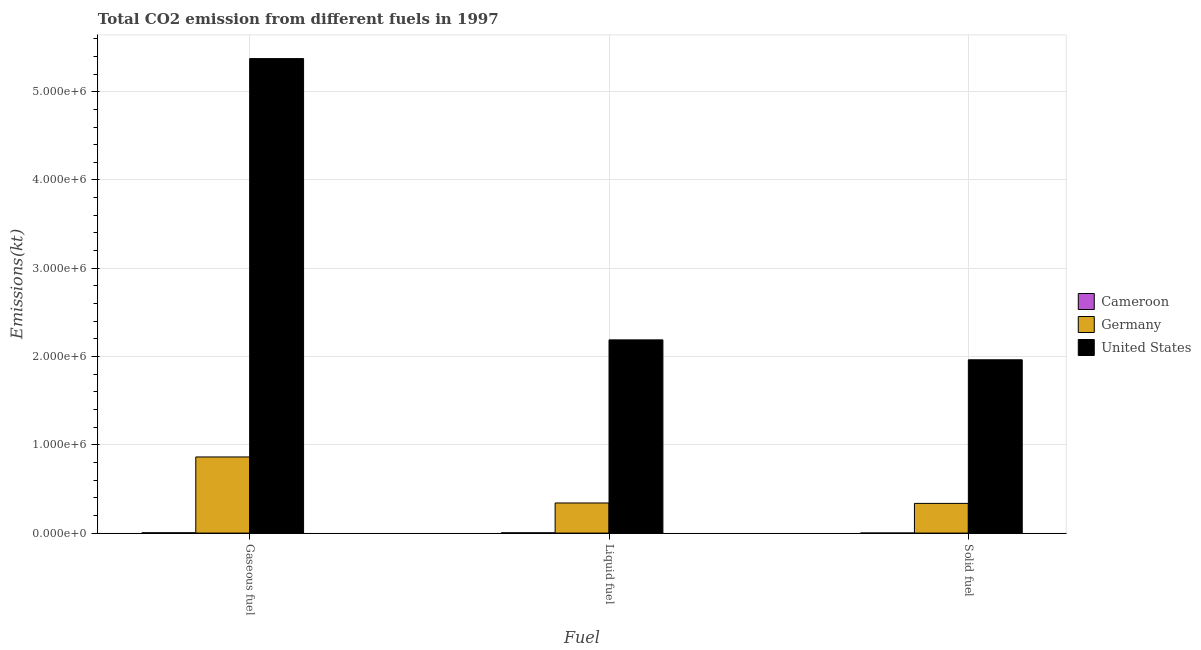How many different coloured bars are there?
Keep it short and to the point. 3. How many groups of bars are there?
Your response must be concise. 3. How many bars are there on the 3rd tick from the left?
Give a very brief answer. 3. How many bars are there on the 3rd tick from the right?
Your answer should be compact. 3. What is the label of the 1st group of bars from the left?
Keep it short and to the point. Gaseous fuel. What is the amount of co2 emissions from liquid fuel in Germany?
Your answer should be very brief. 3.41e+05. Across all countries, what is the maximum amount of co2 emissions from solid fuel?
Ensure brevity in your answer.  1.96e+06. Across all countries, what is the minimum amount of co2 emissions from gaseous fuel?
Keep it short and to the point. 3215.96. In which country was the amount of co2 emissions from liquid fuel minimum?
Your response must be concise. Cameroon. What is the total amount of co2 emissions from liquid fuel in the graph?
Provide a short and direct response. 2.53e+06. What is the difference between the amount of co2 emissions from liquid fuel in United States and that in Cameroon?
Your response must be concise. 2.19e+06. What is the difference between the amount of co2 emissions from solid fuel in Cameroon and the amount of co2 emissions from liquid fuel in United States?
Your answer should be very brief. -2.19e+06. What is the average amount of co2 emissions from liquid fuel per country?
Your answer should be very brief. 8.44e+05. What is the difference between the amount of co2 emissions from gaseous fuel and amount of co2 emissions from liquid fuel in Cameroon?
Provide a short and direct response. 311.7. What is the ratio of the amount of co2 emissions from liquid fuel in Germany to that in United States?
Make the answer very short. 0.16. What is the difference between the highest and the second highest amount of co2 emissions from gaseous fuel?
Your answer should be very brief. 4.51e+06. What is the difference between the highest and the lowest amount of co2 emissions from gaseous fuel?
Offer a very short reply. 5.37e+06. What does the 1st bar from the right in Gaseous fuel represents?
Make the answer very short. United States. How many bars are there?
Ensure brevity in your answer.  9. What is the difference between two consecutive major ticks on the Y-axis?
Offer a very short reply. 1.00e+06. Are the values on the major ticks of Y-axis written in scientific E-notation?
Your answer should be compact. Yes. Does the graph contain any zero values?
Your answer should be compact. No. Does the graph contain grids?
Offer a terse response. Yes. How many legend labels are there?
Ensure brevity in your answer.  3. How are the legend labels stacked?
Offer a terse response. Vertical. What is the title of the graph?
Offer a very short reply. Total CO2 emission from different fuels in 1997. What is the label or title of the X-axis?
Offer a very short reply. Fuel. What is the label or title of the Y-axis?
Make the answer very short. Emissions(kt). What is the Emissions(kt) of Cameroon in Gaseous fuel?
Provide a succinct answer. 3215.96. What is the Emissions(kt) in Germany in Gaseous fuel?
Provide a succinct answer. 8.62e+05. What is the Emissions(kt) of United States in Gaseous fuel?
Offer a very short reply. 5.38e+06. What is the Emissions(kt) in Cameroon in Liquid fuel?
Provide a short and direct response. 2904.26. What is the Emissions(kt) of Germany in Liquid fuel?
Provide a succinct answer. 3.41e+05. What is the Emissions(kt) of United States in Liquid fuel?
Give a very brief answer. 2.19e+06. What is the Emissions(kt) in Cameroon in Solid fuel?
Offer a terse response. 3.67. What is the Emissions(kt) of Germany in Solid fuel?
Your response must be concise. 3.36e+05. What is the Emissions(kt) of United States in Solid fuel?
Make the answer very short. 1.96e+06. Across all Fuel, what is the maximum Emissions(kt) in Cameroon?
Your answer should be compact. 3215.96. Across all Fuel, what is the maximum Emissions(kt) of Germany?
Give a very brief answer. 8.62e+05. Across all Fuel, what is the maximum Emissions(kt) of United States?
Offer a very short reply. 5.38e+06. Across all Fuel, what is the minimum Emissions(kt) in Cameroon?
Keep it short and to the point. 3.67. Across all Fuel, what is the minimum Emissions(kt) of Germany?
Your answer should be compact. 3.36e+05. Across all Fuel, what is the minimum Emissions(kt) of United States?
Make the answer very short. 1.96e+06. What is the total Emissions(kt) of Cameroon in the graph?
Offer a terse response. 6123.89. What is the total Emissions(kt) in Germany in the graph?
Make the answer very short. 1.54e+06. What is the total Emissions(kt) of United States in the graph?
Offer a terse response. 9.53e+06. What is the difference between the Emissions(kt) of Cameroon in Gaseous fuel and that in Liquid fuel?
Your answer should be very brief. 311.69. What is the difference between the Emissions(kt) of Germany in Gaseous fuel and that in Liquid fuel?
Ensure brevity in your answer.  5.21e+05. What is the difference between the Emissions(kt) of United States in Gaseous fuel and that in Liquid fuel?
Your answer should be compact. 3.19e+06. What is the difference between the Emissions(kt) of Cameroon in Gaseous fuel and that in Solid fuel?
Offer a terse response. 3212.29. What is the difference between the Emissions(kt) in Germany in Gaseous fuel and that in Solid fuel?
Provide a succinct answer. 5.26e+05. What is the difference between the Emissions(kt) in United States in Gaseous fuel and that in Solid fuel?
Your answer should be very brief. 3.41e+06. What is the difference between the Emissions(kt) of Cameroon in Liquid fuel and that in Solid fuel?
Offer a very short reply. 2900.6. What is the difference between the Emissions(kt) in Germany in Liquid fuel and that in Solid fuel?
Your answer should be very brief. 4807.44. What is the difference between the Emissions(kt) of United States in Liquid fuel and that in Solid fuel?
Keep it short and to the point. 2.26e+05. What is the difference between the Emissions(kt) in Cameroon in Gaseous fuel and the Emissions(kt) in Germany in Liquid fuel?
Your answer should be compact. -3.38e+05. What is the difference between the Emissions(kt) of Cameroon in Gaseous fuel and the Emissions(kt) of United States in Liquid fuel?
Your answer should be very brief. -2.19e+06. What is the difference between the Emissions(kt) in Germany in Gaseous fuel and the Emissions(kt) in United States in Liquid fuel?
Give a very brief answer. -1.33e+06. What is the difference between the Emissions(kt) in Cameroon in Gaseous fuel and the Emissions(kt) in Germany in Solid fuel?
Make the answer very short. -3.33e+05. What is the difference between the Emissions(kt) of Cameroon in Gaseous fuel and the Emissions(kt) of United States in Solid fuel?
Offer a terse response. -1.96e+06. What is the difference between the Emissions(kt) of Germany in Gaseous fuel and the Emissions(kt) of United States in Solid fuel?
Ensure brevity in your answer.  -1.10e+06. What is the difference between the Emissions(kt) of Cameroon in Liquid fuel and the Emissions(kt) of Germany in Solid fuel?
Your response must be concise. -3.33e+05. What is the difference between the Emissions(kt) of Cameroon in Liquid fuel and the Emissions(kt) of United States in Solid fuel?
Give a very brief answer. -1.96e+06. What is the difference between the Emissions(kt) in Germany in Liquid fuel and the Emissions(kt) in United States in Solid fuel?
Your answer should be compact. -1.62e+06. What is the average Emissions(kt) in Cameroon per Fuel?
Your answer should be very brief. 2041.3. What is the average Emissions(kt) in Germany per Fuel?
Give a very brief answer. 5.13e+05. What is the average Emissions(kt) in United States per Fuel?
Ensure brevity in your answer.  3.18e+06. What is the difference between the Emissions(kt) in Cameroon and Emissions(kt) in Germany in Gaseous fuel?
Keep it short and to the point. -8.59e+05. What is the difference between the Emissions(kt) in Cameroon and Emissions(kt) in United States in Gaseous fuel?
Ensure brevity in your answer.  -5.37e+06. What is the difference between the Emissions(kt) in Germany and Emissions(kt) in United States in Gaseous fuel?
Ensure brevity in your answer.  -4.51e+06. What is the difference between the Emissions(kt) in Cameroon and Emissions(kt) in Germany in Liquid fuel?
Give a very brief answer. -3.38e+05. What is the difference between the Emissions(kt) in Cameroon and Emissions(kt) in United States in Liquid fuel?
Ensure brevity in your answer.  -2.19e+06. What is the difference between the Emissions(kt) of Germany and Emissions(kt) of United States in Liquid fuel?
Offer a terse response. -1.85e+06. What is the difference between the Emissions(kt) of Cameroon and Emissions(kt) of Germany in Solid fuel?
Provide a succinct answer. -3.36e+05. What is the difference between the Emissions(kt) in Cameroon and Emissions(kt) in United States in Solid fuel?
Make the answer very short. -1.96e+06. What is the difference between the Emissions(kt) of Germany and Emissions(kt) of United States in Solid fuel?
Your response must be concise. -1.63e+06. What is the ratio of the Emissions(kt) in Cameroon in Gaseous fuel to that in Liquid fuel?
Your answer should be compact. 1.11. What is the ratio of the Emissions(kt) in Germany in Gaseous fuel to that in Liquid fuel?
Offer a very short reply. 2.53. What is the ratio of the Emissions(kt) in United States in Gaseous fuel to that in Liquid fuel?
Ensure brevity in your answer.  2.46. What is the ratio of the Emissions(kt) of Cameroon in Gaseous fuel to that in Solid fuel?
Provide a succinct answer. 877. What is the ratio of the Emissions(kt) of Germany in Gaseous fuel to that in Solid fuel?
Your answer should be compact. 2.57. What is the ratio of the Emissions(kt) of United States in Gaseous fuel to that in Solid fuel?
Ensure brevity in your answer.  2.74. What is the ratio of the Emissions(kt) of Cameroon in Liquid fuel to that in Solid fuel?
Offer a terse response. 792. What is the ratio of the Emissions(kt) in Germany in Liquid fuel to that in Solid fuel?
Keep it short and to the point. 1.01. What is the ratio of the Emissions(kt) in United States in Liquid fuel to that in Solid fuel?
Provide a succinct answer. 1.11. What is the difference between the highest and the second highest Emissions(kt) in Cameroon?
Ensure brevity in your answer.  311.69. What is the difference between the highest and the second highest Emissions(kt) in Germany?
Ensure brevity in your answer.  5.21e+05. What is the difference between the highest and the second highest Emissions(kt) of United States?
Your response must be concise. 3.19e+06. What is the difference between the highest and the lowest Emissions(kt) of Cameroon?
Provide a succinct answer. 3212.29. What is the difference between the highest and the lowest Emissions(kt) of Germany?
Provide a short and direct response. 5.26e+05. What is the difference between the highest and the lowest Emissions(kt) in United States?
Give a very brief answer. 3.41e+06. 